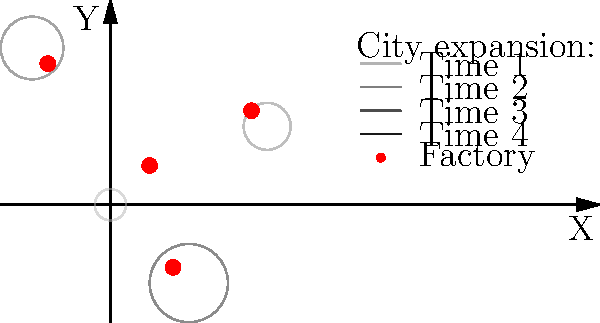Analyze the map showing factory locations and city expansion over time. Calculate the Pearson correlation coefficient ($r$) between the distance of factories from the nearest city center at Time 1 and the growth rate of that city between Time 1 and Time 4. What does this correlation suggest about the relationship between factory proximity and urban growth during the industrial revolution? To answer this question, we need to follow these steps:

1. Identify the nearest city for each factory at Time 1.
2. Calculate the distance between each factory and its nearest city center.
3. Calculate the growth rate of each city from Time 1 to Time 4.
4. Calculate the Pearson correlation coefficient between factory distances and city growth rates.

Step 1: Nearest city for each factory (visually determined):
- Factory 1 (0.5, 0.5) → City 1 (0, 0)
- Factory 2 (1.8, 1.2) → City 2 (2, 1)
- Factory 3 (-0.8, 1.8) → City 3 (-1, 2)
- Factory 4 (0.8, -0.8) → City 4 (1, -1)

Step 2: Calculate distances:
- d1 = $\sqrt{(0.5-0)^2 + (0.5-0)^2} = 0.71$
- d2 = $\sqrt{(1.8-2)^2 + (1.2-1)^2} = 0.28$
- d3 = $\sqrt{(-0.8+1)^2 + (1.8-2)^2} = 0.28$
- d4 = $\sqrt{(0.8-1)^2 + (-0.8+1)^2} = 0.28$

Step 3: Calculate growth rates (assuming linear growth):
- g1 = (0.5 - 0.2) / 0.2 = 1.5
- g2 = (0.5 - 0.2) / 0.2 = 1.5
- g3 = (0.5 - 0.2) / 0.2 = 1.5
- g4 = (0.5 - 0.2) / 0.2 = 1.5

Step 4: Calculate Pearson correlation coefficient:
$r = \frac{\sum{(x_i - \bar{x})(y_i - \bar{y})}}{\sqrt{\sum{(x_i - \bar{x})^2}\sum{(y_i - \bar{y})^2}}}$

Where $x_i$ are the distances and $y_i$ are the growth rates.

$\bar{x} = 0.3875$, $\bar{y} = 1.5$

$r = \frac{(0.71-0.3875)(1.5-1.5) + 3(0.28-0.3875)(1.5-1.5)}{\sqrt{(0.71-0.3875)^2 + 3(0.28-0.3875)^2} \sqrt{4(1.5-1.5)^2}} = 0$

The correlation coefficient is 0, suggesting no linear relationship between factory proximity and urban growth rate in this scenario.
Answer: $r = 0$, indicating no linear correlation between factory proximity and urban growth rate. 